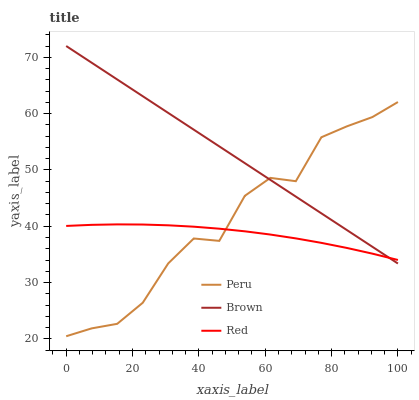Does Red have the minimum area under the curve?
Answer yes or no. Yes. Does Brown have the maximum area under the curve?
Answer yes or no. Yes. Does Peru have the minimum area under the curve?
Answer yes or no. No. Does Peru have the maximum area under the curve?
Answer yes or no. No. Is Brown the smoothest?
Answer yes or no. Yes. Is Peru the roughest?
Answer yes or no. Yes. Is Red the smoothest?
Answer yes or no. No. Is Red the roughest?
Answer yes or no. No. Does Red have the lowest value?
Answer yes or no. No. Does Brown have the highest value?
Answer yes or no. Yes. Does Peru have the highest value?
Answer yes or no. No. Does Brown intersect Peru?
Answer yes or no. Yes. Is Brown less than Peru?
Answer yes or no. No. Is Brown greater than Peru?
Answer yes or no. No. 